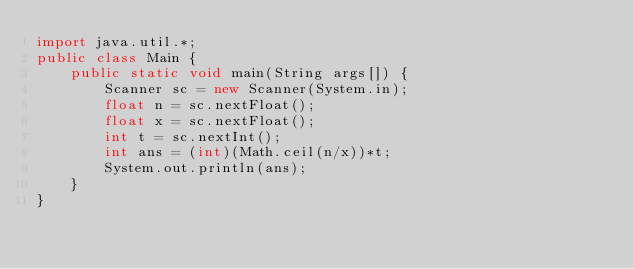<code> <loc_0><loc_0><loc_500><loc_500><_Java_>import java.util.*;
public class Main {
    public static void main(String args[]) {
        Scanner sc = new Scanner(System.in);
        float n = sc.nextFloat();
        float x = sc.nextFloat();
        int t = sc.nextInt();
        int ans = (int)(Math.ceil(n/x))*t;
        System.out.println(ans);
    }
}</code> 